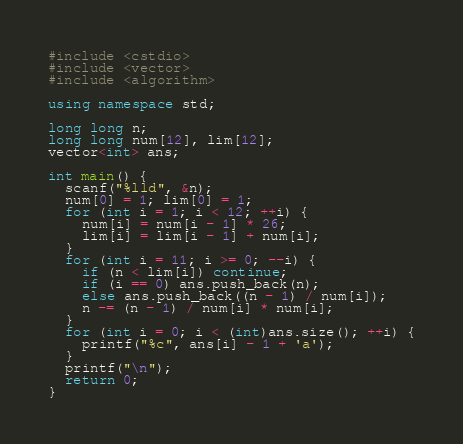Convert code to text. <code><loc_0><loc_0><loc_500><loc_500><_C++_>#include <cstdio>
#include <vector>
#include <algorithm>

using namespace std;

long long n;
long long num[12], lim[12];
vector<int> ans;

int main() {
  scanf("%lld", &n);
  num[0] = 1; lim[0] = 1;
  for (int i = 1; i < 12; ++i) {
    num[i] = num[i - 1] * 26;
    lim[i] = lim[i - 1] + num[i];
  }
  for (int i = 11; i >= 0; --i) {
    if (n < lim[i]) continue;
    if (i == 0) ans.push_back(n);
    else ans.push_back((n - 1) / num[i]);
    n -= (n - 1) / num[i] * num[i];
  }
  for (int i = 0; i < (int)ans.size(); ++i) {
    printf("%c", ans[i] - 1 + 'a');
  }
  printf("\n");
  return 0;
}</code> 